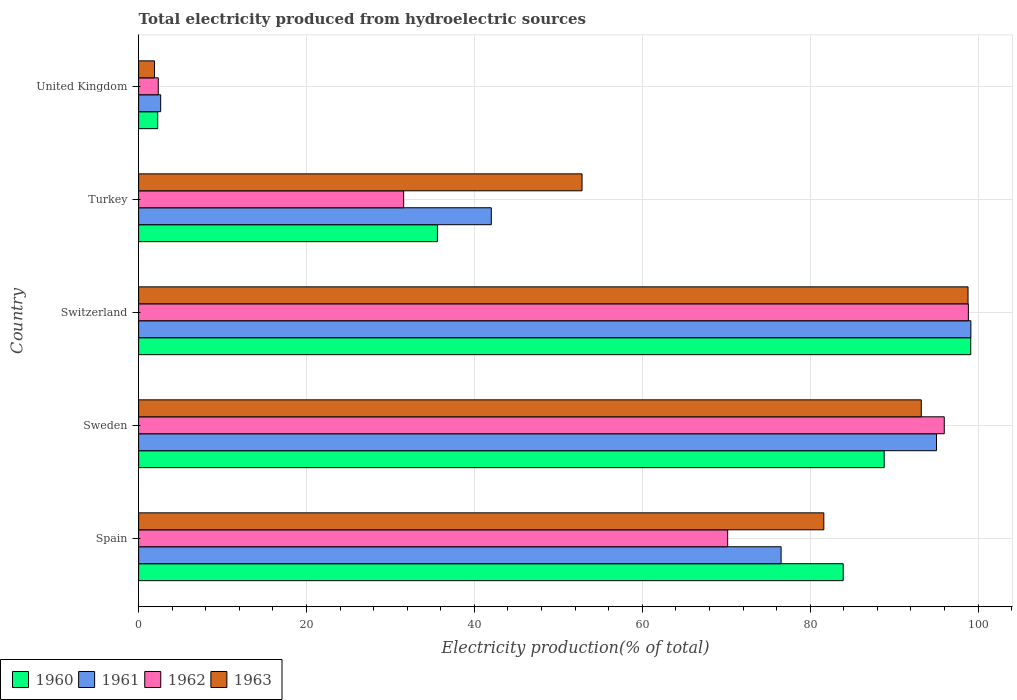How many groups of bars are there?
Make the answer very short. 5. Are the number of bars on each tick of the Y-axis equal?
Ensure brevity in your answer.  Yes. What is the label of the 5th group of bars from the top?
Provide a succinct answer. Spain. What is the total electricity produced in 1960 in Spain?
Keep it short and to the point. 83.94. Across all countries, what is the maximum total electricity produced in 1961?
Give a very brief answer. 99.15. Across all countries, what is the minimum total electricity produced in 1962?
Give a very brief answer. 2.34. In which country was the total electricity produced in 1962 maximum?
Provide a short and direct response. Switzerland. What is the total total electricity produced in 1962 in the graph?
Offer a terse response. 298.91. What is the difference between the total electricity produced in 1960 in Spain and that in Sweden?
Your response must be concise. -4.88. What is the difference between the total electricity produced in 1962 in Sweden and the total electricity produced in 1960 in United Kingdom?
Your answer should be compact. 93.7. What is the average total electricity produced in 1963 per country?
Ensure brevity in your answer.  65.68. What is the difference between the total electricity produced in 1961 and total electricity produced in 1962 in Sweden?
Make the answer very short. -0.93. What is the ratio of the total electricity produced in 1961 in Sweden to that in United Kingdom?
Your answer should be compact. 36.19. Is the total electricity produced in 1960 in Switzerland less than that in Turkey?
Your response must be concise. No. Is the difference between the total electricity produced in 1961 in Turkey and United Kingdom greater than the difference between the total electricity produced in 1962 in Turkey and United Kingdom?
Your response must be concise. Yes. What is the difference between the highest and the second highest total electricity produced in 1960?
Your answer should be compact. 10.31. What is the difference between the highest and the lowest total electricity produced in 1961?
Your answer should be compact. 96.52. In how many countries, is the total electricity produced in 1960 greater than the average total electricity produced in 1960 taken over all countries?
Ensure brevity in your answer.  3. Is the sum of the total electricity produced in 1962 in Sweden and Turkey greater than the maximum total electricity produced in 1963 across all countries?
Your response must be concise. Yes. Is it the case that in every country, the sum of the total electricity produced in 1960 and total electricity produced in 1963 is greater than the sum of total electricity produced in 1962 and total electricity produced in 1961?
Offer a very short reply. No. What does the 1st bar from the top in United Kingdom represents?
Make the answer very short. 1963. What does the 4th bar from the bottom in Spain represents?
Provide a short and direct response. 1963. How many bars are there?
Provide a succinct answer. 20. Are all the bars in the graph horizontal?
Ensure brevity in your answer.  Yes. How many countries are there in the graph?
Offer a very short reply. 5. What is the difference between two consecutive major ticks on the X-axis?
Give a very brief answer. 20. Are the values on the major ticks of X-axis written in scientific E-notation?
Provide a succinct answer. No. Does the graph contain grids?
Make the answer very short. Yes. How many legend labels are there?
Ensure brevity in your answer.  4. What is the title of the graph?
Your answer should be compact. Total electricity produced from hydroelectric sources. Does "2008" appear as one of the legend labels in the graph?
Your answer should be very brief. No. What is the Electricity production(% of total) of 1960 in Spain?
Offer a terse response. 83.94. What is the Electricity production(% of total) in 1961 in Spain?
Your response must be concise. 76.54. What is the Electricity production(% of total) of 1962 in Spain?
Give a very brief answer. 70.17. What is the Electricity production(% of total) in 1963 in Spain?
Provide a short and direct response. 81.63. What is the Electricity production(% of total) of 1960 in Sweden?
Ensure brevity in your answer.  88.82. What is the Electricity production(% of total) in 1961 in Sweden?
Give a very brief answer. 95.05. What is the Electricity production(% of total) of 1962 in Sweden?
Offer a terse response. 95.98. What is the Electricity production(% of total) of 1963 in Sweden?
Keep it short and to the point. 93.24. What is the Electricity production(% of total) in 1960 in Switzerland?
Ensure brevity in your answer.  99.13. What is the Electricity production(% of total) of 1961 in Switzerland?
Give a very brief answer. 99.15. What is the Electricity production(% of total) in 1962 in Switzerland?
Make the answer very short. 98.85. What is the Electricity production(% of total) of 1963 in Switzerland?
Give a very brief answer. 98.81. What is the Electricity production(% of total) of 1960 in Turkey?
Offer a very short reply. 35.6. What is the Electricity production(% of total) of 1961 in Turkey?
Your answer should be compact. 42.01. What is the Electricity production(% of total) in 1962 in Turkey?
Provide a short and direct response. 31.57. What is the Electricity production(% of total) of 1963 in Turkey?
Your response must be concise. 52.82. What is the Electricity production(% of total) in 1960 in United Kingdom?
Provide a short and direct response. 2.27. What is the Electricity production(% of total) in 1961 in United Kingdom?
Provide a short and direct response. 2.63. What is the Electricity production(% of total) in 1962 in United Kingdom?
Your answer should be compact. 2.34. What is the Electricity production(% of total) of 1963 in United Kingdom?
Your answer should be compact. 1.89. Across all countries, what is the maximum Electricity production(% of total) of 1960?
Offer a very short reply. 99.13. Across all countries, what is the maximum Electricity production(% of total) of 1961?
Offer a very short reply. 99.15. Across all countries, what is the maximum Electricity production(% of total) in 1962?
Your answer should be very brief. 98.85. Across all countries, what is the maximum Electricity production(% of total) in 1963?
Ensure brevity in your answer.  98.81. Across all countries, what is the minimum Electricity production(% of total) in 1960?
Your answer should be very brief. 2.27. Across all countries, what is the minimum Electricity production(% of total) in 1961?
Your response must be concise. 2.63. Across all countries, what is the minimum Electricity production(% of total) in 1962?
Make the answer very short. 2.34. Across all countries, what is the minimum Electricity production(% of total) in 1963?
Offer a terse response. 1.89. What is the total Electricity production(% of total) in 1960 in the graph?
Your answer should be very brief. 309.75. What is the total Electricity production(% of total) of 1961 in the graph?
Provide a short and direct response. 315.37. What is the total Electricity production(% of total) in 1962 in the graph?
Ensure brevity in your answer.  298.91. What is the total Electricity production(% of total) of 1963 in the graph?
Give a very brief answer. 328.39. What is the difference between the Electricity production(% of total) in 1960 in Spain and that in Sweden?
Keep it short and to the point. -4.88. What is the difference between the Electricity production(% of total) in 1961 in Spain and that in Sweden?
Ensure brevity in your answer.  -18.51. What is the difference between the Electricity production(% of total) in 1962 in Spain and that in Sweden?
Your answer should be very brief. -25.8. What is the difference between the Electricity production(% of total) in 1963 in Spain and that in Sweden?
Provide a succinct answer. -11.61. What is the difference between the Electricity production(% of total) of 1960 in Spain and that in Switzerland?
Provide a short and direct response. -15.19. What is the difference between the Electricity production(% of total) in 1961 in Spain and that in Switzerland?
Ensure brevity in your answer.  -22.61. What is the difference between the Electricity production(% of total) in 1962 in Spain and that in Switzerland?
Offer a very short reply. -28.67. What is the difference between the Electricity production(% of total) in 1963 in Spain and that in Switzerland?
Your answer should be compact. -17.18. What is the difference between the Electricity production(% of total) of 1960 in Spain and that in Turkey?
Your answer should be compact. 48.34. What is the difference between the Electricity production(% of total) of 1961 in Spain and that in Turkey?
Your answer should be compact. 34.53. What is the difference between the Electricity production(% of total) of 1962 in Spain and that in Turkey?
Give a very brief answer. 38.6. What is the difference between the Electricity production(% of total) of 1963 in Spain and that in Turkey?
Give a very brief answer. 28.8. What is the difference between the Electricity production(% of total) in 1960 in Spain and that in United Kingdom?
Provide a short and direct response. 81.66. What is the difference between the Electricity production(% of total) in 1961 in Spain and that in United Kingdom?
Your answer should be compact. 73.91. What is the difference between the Electricity production(% of total) of 1962 in Spain and that in United Kingdom?
Provide a short and direct response. 67.83. What is the difference between the Electricity production(% of total) in 1963 in Spain and that in United Kingdom?
Provide a succinct answer. 79.73. What is the difference between the Electricity production(% of total) in 1960 in Sweden and that in Switzerland?
Give a very brief answer. -10.31. What is the difference between the Electricity production(% of total) of 1961 in Sweden and that in Switzerland?
Your response must be concise. -4.1. What is the difference between the Electricity production(% of total) in 1962 in Sweden and that in Switzerland?
Provide a short and direct response. -2.87. What is the difference between the Electricity production(% of total) of 1963 in Sweden and that in Switzerland?
Make the answer very short. -5.57. What is the difference between the Electricity production(% of total) of 1960 in Sweden and that in Turkey?
Give a very brief answer. 53.22. What is the difference between the Electricity production(% of total) of 1961 in Sweden and that in Turkey?
Offer a terse response. 53.04. What is the difference between the Electricity production(% of total) in 1962 in Sweden and that in Turkey?
Provide a succinct answer. 64.4. What is the difference between the Electricity production(% of total) of 1963 in Sweden and that in Turkey?
Your answer should be compact. 40.41. What is the difference between the Electricity production(% of total) of 1960 in Sweden and that in United Kingdom?
Your answer should be very brief. 86.55. What is the difference between the Electricity production(% of total) of 1961 in Sweden and that in United Kingdom?
Ensure brevity in your answer.  92.42. What is the difference between the Electricity production(% of total) in 1962 in Sweden and that in United Kingdom?
Ensure brevity in your answer.  93.64. What is the difference between the Electricity production(% of total) in 1963 in Sweden and that in United Kingdom?
Provide a short and direct response. 91.34. What is the difference between the Electricity production(% of total) in 1960 in Switzerland and that in Turkey?
Provide a short and direct response. 63.54. What is the difference between the Electricity production(% of total) of 1961 in Switzerland and that in Turkey?
Make the answer very short. 57.13. What is the difference between the Electricity production(% of total) of 1962 in Switzerland and that in Turkey?
Your answer should be very brief. 67.27. What is the difference between the Electricity production(% of total) of 1963 in Switzerland and that in Turkey?
Make the answer very short. 45.98. What is the difference between the Electricity production(% of total) in 1960 in Switzerland and that in United Kingdom?
Offer a terse response. 96.86. What is the difference between the Electricity production(% of total) of 1961 in Switzerland and that in United Kingdom?
Give a very brief answer. 96.52. What is the difference between the Electricity production(% of total) of 1962 in Switzerland and that in United Kingdom?
Ensure brevity in your answer.  96.51. What is the difference between the Electricity production(% of total) in 1963 in Switzerland and that in United Kingdom?
Your response must be concise. 96.91. What is the difference between the Electricity production(% of total) of 1960 in Turkey and that in United Kingdom?
Ensure brevity in your answer.  33.32. What is the difference between the Electricity production(% of total) of 1961 in Turkey and that in United Kingdom?
Offer a terse response. 39.39. What is the difference between the Electricity production(% of total) of 1962 in Turkey and that in United Kingdom?
Your response must be concise. 29.23. What is the difference between the Electricity production(% of total) of 1963 in Turkey and that in United Kingdom?
Your answer should be compact. 50.93. What is the difference between the Electricity production(% of total) in 1960 in Spain and the Electricity production(% of total) in 1961 in Sweden?
Give a very brief answer. -11.11. What is the difference between the Electricity production(% of total) of 1960 in Spain and the Electricity production(% of total) of 1962 in Sweden?
Keep it short and to the point. -12.04. What is the difference between the Electricity production(% of total) of 1960 in Spain and the Electricity production(% of total) of 1963 in Sweden?
Your answer should be compact. -9.3. What is the difference between the Electricity production(% of total) in 1961 in Spain and the Electricity production(% of total) in 1962 in Sweden?
Provide a succinct answer. -19.44. What is the difference between the Electricity production(% of total) of 1961 in Spain and the Electricity production(% of total) of 1963 in Sweden?
Give a very brief answer. -16.7. What is the difference between the Electricity production(% of total) in 1962 in Spain and the Electricity production(% of total) in 1963 in Sweden?
Keep it short and to the point. -23.06. What is the difference between the Electricity production(% of total) in 1960 in Spain and the Electricity production(% of total) in 1961 in Switzerland?
Keep it short and to the point. -15.21. What is the difference between the Electricity production(% of total) in 1960 in Spain and the Electricity production(% of total) in 1962 in Switzerland?
Provide a short and direct response. -14.91. What is the difference between the Electricity production(% of total) of 1960 in Spain and the Electricity production(% of total) of 1963 in Switzerland?
Provide a short and direct response. -14.87. What is the difference between the Electricity production(% of total) in 1961 in Spain and the Electricity production(% of total) in 1962 in Switzerland?
Make the answer very short. -22.31. What is the difference between the Electricity production(% of total) in 1961 in Spain and the Electricity production(% of total) in 1963 in Switzerland?
Give a very brief answer. -22.27. What is the difference between the Electricity production(% of total) of 1962 in Spain and the Electricity production(% of total) of 1963 in Switzerland?
Offer a terse response. -28.63. What is the difference between the Electricity production(% of total) in 1960 in Spain and the Electricity production(% of total) in 1961 in Turkey?
Your response must be concise. 41.92. What is the difference between the Electricity production(% of total) in 1960 in Spain and the Electricity production(% of total) in 1962 in Turkey?
Ensure brevity in your answer.  52.36. What is the difference between the Electricity production(% of total) in 1960 in Spain and the Electricity production(% of total) in 1963 in Turkey?
Provide a succinct answer. 31.11. What is the difference between the Electricity production(% of total) of 1961 in Spain and the Electricity production(% of total) of 1962 in Turkey?
Keep it short and to the point. 44.97. What is the difference between the Electricity production(% of total) in 1961 in Spain and the Electricity production(% of total) in 1963 in Turkey?
Offer a terse response. 23.72. What is the difference between the Electricity production(% of total) of 1962 in Spain and the Electricity production(% of total) of 1963 in Turkey?
Give a very brief answer. 17.35. What is the difference between the Electricity production(% of total) in 1960 in Spain and the Electricity production(% of total) in 1961 in United Kingdom?
Offer a terse response. 81.31. What is the difference between the Electricity production(% of total) in 1960 in Spain and the Electricity production(% of total) in 1962 in United Kingdom?
Provide a short and direct response. 81.6. What is the difference between the Electricity production(% of total) of 1960 in Spain and the Electricity production(% of total) of 1963 in United Kingdom?
Your response must be concise. 82.04. What is the difference between the Electricity production(% of total) of 1961 in Spain and the Electricity production(% of total) of 1962 in United Kingdom?
Provide a succinct answer. 74.2. What is the difference between the Electricity production(% of total) of 1961 in Spain and the Electricity production(% of total) of 1963 in United Kingdom?
Make the answer very short. 74.65. What is the difference between the Electricity production(% of total) in 1962 in Spain and the Electricity production(% of total) in 1963 in United Kingdom?
Provide a succinct answer. 68.28. What is the difference between the Electricity production(% of total) in 1960 in Sweden and the Electricity production(% of total) in 1961 in Switzerland?
Give a very brief answer. -10.33. What is the difference between the Electricity production(% of total) of 1960 in Sweden and the Electricity production(% of total) of 1962 in Switzerland?
Your answer should be compact. -10.03. What is the difference between the Electricity production(% of total) in 1960 in Sweden and the Electricity production(% of total) in 1963 in Switzerland?
Your response must be concise. -9.99. What is the difference between the Electricity production(% of total) in 1961 in Sweden and the Electricity production(% of total) in 1962 in Switzerland?
Your answer should be very brief. -3.8. What is the difference between the Electricity production(% of total) of 1961 in Sweden and the Electricity production(% of total) of 1963 in Switzerland?
Your response must be concise. -3.76. What is the difference between the Electricity production(% of total) in 1962 in Sweden and the Electricity production(% of total) in 1963 in Switzerland?
Your answer should be compact. -2.83. What is the difference between the Electricity production(% of total) of 1960 in Sweden and the Electricity production(% of total) of 1961 in Turkey?
Make the answer very short. 46.81. What is the difference between the Electricity production(% of total) of 1960 in Sweden and the Electricity production(% of total) of 1962 in Turkey?
Ensure brevity in your answer.  57.25. What is the difference between the Electricity production(% of total) of 1960 in Sweden and the Electricity production(% of total) of 1963 in Turkey?
Ensure brevity in your answer.  36. What is the difference between the Electricity production(% of total) in 1961 in Sweden and the Electricity production(% of total) in 1962 in Turkey?
Keep it short and to the point. 63.48. What is the difference between the Electricity production(% of total) in 1961 in Sweden and the Electricity production(% of total) in 1963 in Turkey?
Provide a succinct answer. 42.22. What is the difference between the Electricity production(% of total) of 1962 in Sweden and the Electricity production(% of total) of 1963 in Turkey?
Your answer should be compact. 43.15. What is the difference between the Electricity production(% of total) in 1960 in Sweden and the Electricity production(% of total) in 1961 in United Kingdom?
Make the answer very short. 86.19. What is the difference between the Electricity production(% of total) of 1960 in Sweden and the Electricity production(% of total) of 1962 in United Kingdom?
Your answer should be very brief. 86.48. What is the difference between the Electricity production(% of total) in 1960 in Sweden and the Electricity production(% of total) in 1963 in United Kingdom?
Offer a very short reply. 86.93. What is the difference between the Electricity production(% of total) of 1961 in Sweden and the Electricity production(% of total) of 1962 in United Kingdom?
Your response must be concise. 92.71. What is the difference between the Electricity production(% of total) of 1961 in Sweden and the Electricity production(% of total) of 1963 in United Kingdom?
Give a very brief answer. 93.15. What is the difference between the Electricity production(% of total) of 1962 in Sweden and the Electricity production(% of total) of 1963 in United Kingdom?
Your answer should be compact. 94.08. What is the difference between the Electricity production(% of total) of 1960 in Switzerland and the Electricity production(% of total) of 1961 in Turkey?
Ensure brevity in your answer.  57.12. What is the difference between the Electricity production(% of total) of 1960 in Switzerland and the Electricity production(% of total) of 1962 in Turkey?
Make the answer very short. 67.56. What is the difference between the Electricity production(% of total) in 1960 in Switzerland and the Electricity production(% of total) in 1963 in Turkey?
Offer a terse response. 46.31. What is the difference between the Electricity production(% of total) in 1961 in Switzerland and the Electricity production(% of total) in 1962 in Turkey?
Provide a succinct answer. 67.57. What is the difference between the Electricity production(% of total) in 1961 in Switzerland and the Electricity production(% of total) in 1963 in Turkey?
Make the answer very short. 46.32. What is the difference between the Electricity production(% of total) in 1962 in Switzerland and the Electricity production(% of total) in 1963 in Turkey?
Your answer should be compact. 46.02. What is the difference between the Electricity production(% of total) in 1960 in Switzerland and the Electricity production(% of total) in 1961 in United Kingdom?
Make the answer very short. 96.5. What is the difference between the Electricity production(% of total) of 1960 in Switzerland and the Electricity production(% of total) of 1962 in United Kingdom?
Keep it short and to the point. 96.79. What is the difference between the Electricity production(% of total) of 1960 in Switzerland and the Electricity production(% of total) of 1963 in United Kingdom?
Your answer should be compact. 97.24. What is the difference between the Electricity production(% of total) in 1961 in Switzerland and the Electricity production(% of total) in 1962 in United Kingdom?
Your answer should be very brief. 96.81. What is the difference between the Electricity production(% of total) in 1961 in Switzerland and the Electricity production(% of total) in 1963 in United Kingdom?
Your response must be concise. 97.25. What is the difference between the Electricity production(% of total) in 1962 in Switzerland and the Electricity production(% of total) in 1963 in United Kingdom?
Ensure brevity in your answer.  96.95. What is the difference between the Electricity production(% of total) of 1960 in Turkey and the Electricity production(% of total) of 1961 in United Kingdom?
Your response must be concise. 32.97. What is the difference between the Electricity production(% of total) in 1960 in Turkey and the Electricity production(% of total) in 1962 in United Kingdom?
Your response must be concise. 33.26. What is the difference between the Electricity production(% of total) of 1960 in Turkey and the Electricity production(% of total) of 1963 in United Kingdom?
Ensure brevity in your answer.  33.7. What is the difference between the Electricity production(% of total) in 1961 in Turkey and the Electricity production(% of total) in 1962 in United Kingdom?
Your answer should be very brief. 39.67. What is the difference between the Electricity production(% of total) of 1961 in Turkey and the Electricity production(% of total) of 1963 in United Kingdom?
Ensure brevity in your answer.  40.12. What is the difference between the Electricity production(% of total) of 1962 in Turkey and the Electricity production(% of total) of 1963 in United Kingdom?
Give a very brief answer. 29.68. What is the average Electricity production(% of total) of 1960 per country?
Your response must be concise. 61.95. What is the average Electricity production(% of total) of 1961 per country?
Keep it short and to the point. 63.07. What is the average Electricity production(% of total) in 1962 per country?
Your answer should be very brief. 59.78. What is the average Electricity production(% of total) in 1963 per country?
Your answer should be compact. 65.68. What is the difference between the Electricity production(% of total) in 1960 and Electricity production(% of total) in 1961 in Spain?
Give a very brief answer. 7.4. What is the difference between the Electricity production(% of total) of 1960 and Electricity production(% of total) of 1962 in Spain?
Offer a very short reply. 13.76. What is the difference between the Electricity production(% of total) in 1960 and Electricity production(% of total) in 1963 in Spain?
Your answer should be compact. 2.31. What is the difference between the Electricity production(% of total) in 1961 and Electricity production(% of total) in 1962 in Spain?
Ensure brevity in your answer.  6.37. What is the difference between the Electricity production(% of total) in 1961 and Electricity production(% of total) in 1963 in Spain?
Your response must be concise. -5.09. What is the difference between the Electricity production(% of total) in 1962 and Electricity production(% of total) in 1963 in Spain?
Provide a succinct answer. -11.45. What is the difference between the Electricity production(% of total) in 1960 and Electricity production(% of total) in 1961 in Sweden?
Ensure brevity in your answer.  -6.23. What is the difference between the Electricity production(% of total) in 1960 and Electricity production(% of total) in 1962 in Sweden?
Offer a very short reply. -7.16. What is the difference between the Electricity production(% of total) in 1960 and Electricity production(% of total) in 1963 in Sweden?
Provide a succinct answer. -4.42. What is the difference between the Electricity production(% of total) of 1961 and Electricity production(% of total) of 1962 in Sweden?
Provide a short and direct response. -0.93. What is the difference between the Electricity production(% of total) of 1961 and Electricity production(% of total) of 1963 in Sweden?
Your answer should be very brief. 1.81. What is the difference between the Electricity production(% of total) of 1962 and Electricity production(% of total) of 1963 in Sweden?
Provide a succinct answer. 2.74. What is the difference between the Electricity production(% of total) in 1960 and Electricity production(% of total) in 1961 in Switzerland?
Make the answer very short. -0.02. What is the difference between the Electricity production(% of total) of 1960 and Electricity production(% of total) of 1962 in Switzerland?
Your answer should be very brief. 0.28. What is the difference between the Electricity production(% of total) of 1960 and Electricity production(% of total) of 1963 in Switzerland?
Make the answer very short. 0.32. What is the difference between the Electricity production(% of total) of 1961 and Electricity production(% of total) of 1962 in Switzerland?
Your answer should be compact. 0.3. What is the difference between the Electricity production(% of total) of 1961 and Electricity production(% of total) of 1963 in Switzerland?
Provide a short and direct response. 0.34. What is the difference between the Electricity production(% of total) of 1962 and Electricity production(% of total) of 1963 in Switzerland?
Keep it short and to the point. 0.04. What is the difference between the Electricity production(% of total) in 1960 and Electricity production(% of total) in 1961 in Turkey?
Keep it short and to the point. -6.42. What is the difference between the Electricity production(% of total) in 1960 and Electricity production(% of total) in 1962 in Turkey?
Ensure brevity in your answer.  4.02. What is the difference between the Electricity production(% of total) in 1960 and Electricity production(% of total) in 1963 in Turkey?
Provide a short and direct response. -17.23. What is the difference between the Electricity production(% of total) in 1961 and Electricity production(% of total) in 1962 in Turkey?
Your response must be concise. 10.44. What is the difference between the Electricity production(% of total) of 1961 and Electricity production(% of total) of 1963 in Turkey?
Keep it short and to the point. -10.81. What is the difference between the Electricity production(% of total) of 1962 and Electricity production(% of total) of 1963 in Turkey?
Your answer should be very brief. -21.25. What is the difference between the Electricity production(% of total) of 1960 and Electricity production(% of total) of 1961 in United Kingdom?
Provide a short and direct response. -0.35. What is the difference between the Electricity production(% of total) in 1960 and Electricity production(% of total) in 1962 in United Kingdom?
Provide a succinct answer. -0.07. What is the difference between the Electricity production(% of total) of 1960 and Electricity production(% of total) of 1963 in United Kingdom?
Your answer should be compact. 0.38. What is the difference between the Electricity production(% of total) in 1961 and Electricity production(% of total) in 1962 in United Kingdom?
Offer a terse response. 0.29. What is the difference between the Electricity production(% of total) in 1961 and Electricity production(% of total) in 1963 in United Kingdom?
Your answer should be very brief. 0.73. What is the difference between the Electricity production(% of total) in 1962 and Electricity production(% of total) in 1963 in United Kingdom?
Your answer should be compact. 0.45. What is the ratio of the Electricity production(% of total) in 1960 in Spain to that in Sweden?
Your answer should be compact. 0.94. What is the ratio of the Electricity production(% of total) in 1961 in Spain to that in Sweden?
Your response must be concise. 0.81. What is the ratio of the Electricity production(% of total) in 1962 in Spain to that in Sweden?
Offer a very short reply. 0.73. What is the ratio of the Electricity production(% of total) of 1963 in Spain to that in Sweden?
Provide a succinct answer. 0.88. What is the ratio of the Electricity production(% of total) in 1960 in Spain to that in Switzerland?
Provide a short and direct response. 0.85. What is the ratio of the Electricity production(% of total) of 1961 in Spain to that in Switzerland?
Your answer should be very brief. 0.77. What is the ratio of the Electricity production(% of total) in 1962 in Spain to that in Switzerland?
Your answer should be compact. 0.71. What is the ratio of the Electricity production(% of total) of 1963 in Spain to that in Switzerland?
Provide a succinct answer. 0.83. What is the ratio of the Electricity production(% of total) in 1960 in Spain to that in Turkey?
Make the answer very short. 2.36. What is the ratio of the Electricity production(% of total) in 1961 in Spain to that in Turkey?
Offer a terse response. 1.82. What is the ratio of the Electricity production(% of total) of 1962 in Spain to that in Turkey?
Your answer should be compact. 2.22. What is the ratio of the Electricity production(% of total) of 1963 in Spain to that in Turkey?
Give a very brief answer. 1.55. What is the ratio of the Electricity production(% of total) in 1960 in Spain to that in United Kingdom?
Provide a short and direct response. 36.92. What is the ratio of the Electricity production(% of total) in 1961 in Spain to that in United Kingdom?
Offer a terse response. 29.14. What is the ratio of the Electricity production(% of total) in 1962 in Spain to that in United Kingdom?
Your answer should be very brief. 29.99. What is the ratio of the Electricity production(% of total) of 1963 in Spain to that in United Kingdom?
Your answer should be compact. 43.11. What is the ratio of the Electricity production(% of total) in 1960 in Sweden to that in Switzerland?
Your answer should be compact. 0.9. What is the ratio of the Electricity production(% of total) in 1961 in Sweden to that in Switzerland?
Provide a succinct answer. 0.96. What is the ratio of the Electricity production(% of total) of 1962 in Sweden to that in Switzerland?
Provide a succinct answer. 0.97. What is the ratio of the Electricity production(% of total) in 1963 in Sweden to that in Switzerland?
Your answer should be very brief. 0.94. What is the ratio of the Electricity production(% of total) in 1960 in Sweden to that in Turkey?
Keep it short and to the point. 2.5. What is the ratio of the Electricity production(% of total) of 1961 in Sweden to that in Turkey?
Provide a succinct answer. 2.26. What is the ratio of the Electricity production(% of total) in 1962 in Sweden to that in Turkey?
Your answer should be very brief. 3.04. What is the ratio of the Electricity production(% of total) in 1963 in Sweden to that in Turkey?
Your answer should be very brief. 1.76. What is the ratio of the Electricity production(% of total) in 1960 in Sweden to that in United Kingdom?
Offer a very short reply. 39.07. What is the ratio of the Electricity production(% of total) in 1961 in Sweden to that in United Kingdom?
Make the answer very short. 36.19. What is the ratio of the Electricity production(% of total) in 1962 in Sweden to that in United Kingdom?
Give a very brief answer. 41.02. What is the ratio of the Electricity production(% of total) of 1963 in Sweden to that in United Kingdom?
Your response must be concise. 49.24. What is the ratio of the Electricity production(% of total) of 1960 in Switzerland to that in Turkey?
Provide a short and direct response. 2.79. What is the ratio of the Electricity production(% of total) in 1961 in Switzerland to that in Turkey?
Keep it short and to the point. 2.36. What is the ratio of the Electricity production(% of total) in 1962 in Switzerland to that in Turkey?
Your response must be concise. 3.13. What is the ratio of the Electricity production(% of total) in 1963 in Switzerland to that in Turkey?
Provide a succinct answer. 1.87. What is the ratio of the Electricity production(% of total) in 1960 in Switzerland to that in United Kingdom?
Your answer should be compact. 43.61. What is the ratio of the Electricity production(% of total) of 1961 in Switzerland to that in United Kingdom?
Keep it short and to the point. 37.75. What is the ratio of the Electricity production(% of total) in 1962 in Switzerland to that in United Kingdom?
Provide a succinct answer. 42.24. What is the ratio of the Electricity production(% of total) of 1963 in Switzerland to that in United Kingdom?
Make the answer very short. 52.18. What is the ratio of the Electricity production(% of total) of 1960 in Turkey to that in United Kingdom?
Provide a succinct answer. 15.66. What is the ratio of the Electricity production(% of total) in 1961 in Turkey to that in United Kingdom?
Offer a very short reply. 16. What is the ratio of the Electricity production(% of total) of 1962 in Turkey to that in United Kingdom?
Give a very brief answer. 13.49. What is the ratio of the Electricity production(% of total) in 1963 in Turkey to that in United Kingdom?
Your answer should be very brief. 27.9. What is the difference between the highest and the second highest Electricity production(% of total) of 1960?
Provide a succinct answer. 10.31. What is the difference between the highest and the second highest Electricity production(% of total) in 1961?
Offer a terse response. 4.1. What is the difference between the highest and the second highest Electricity production(% of total) of 1962?
Make the answer very short. 2.87. What is the difference between the highest and the second highest Electricity production(% of total) of 1963?
Give a very brief answer. 5.57. What is the difference between the highest and the lowest Electricity production(% of total) in 1960?
Provide a short and direct response. 96.86. What is the difference between the highest and the lowest Electricity production(% of total) in 1961?
Your answer should be compact. 96.52. What is the difference between the highest and the lowest Electricity production(% of total) of 1962?
Provide a short and direct response. 96.51. What is the difference between the highest and the lowest Electricity production(% of total) in 1963?
Your answer should be very brief. 96.91. 